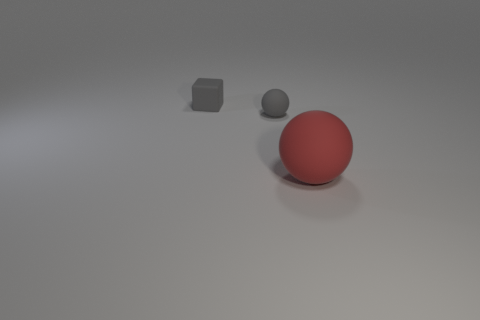Add 2 blue blocks. How many objects exist? 5 Subtract all cubes. How many objects are left? 2 Subtract all purple matte cylinders. Subtract all tiny cubes. How many objects are left? 2 Add 3 gray spheres. How many gray spheres are left? 4 Add 2 small gray rubber balls. How many small gray rubber balls exist? 3 Subtract 1 gray spheres. How many objects are left? 2 